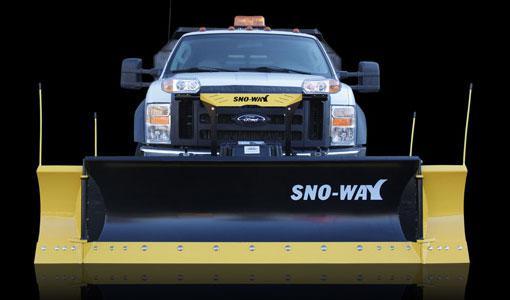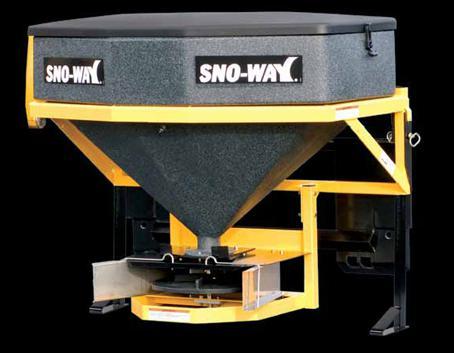The first image is the image on the left, the second image is the image on the right. Evaluate the accuracy of this statement regarding the images: "The right image contains a truck attached to a snow plow that has a yellow lower border.". Is it true? Answer yes or no. No. The first image is the image on the left, the second image is the image on the right. Assess this claim about the two images: "All of the plows are black with a yellow border.". Correct or not? Answer yes or no. Yes. 